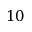<formula> <loc_0><loc_0><loc_500><loc_500>1 0</formula> 